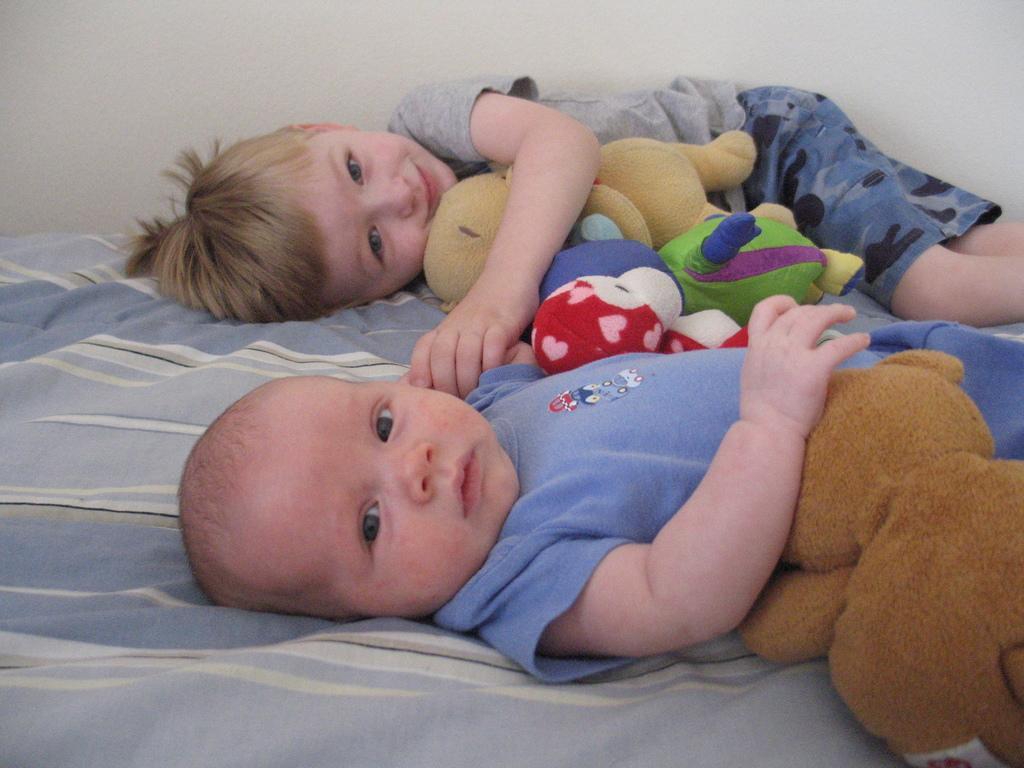Please provide a concise description of this image. In this image I can see two children and I can see both of them are holding soft toys. I can also see a cloth under them. 